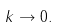Convert formula to latex. <formula><loc_0><loc_0><loc_500><loc_500>\ k \to 0 .</formula> 